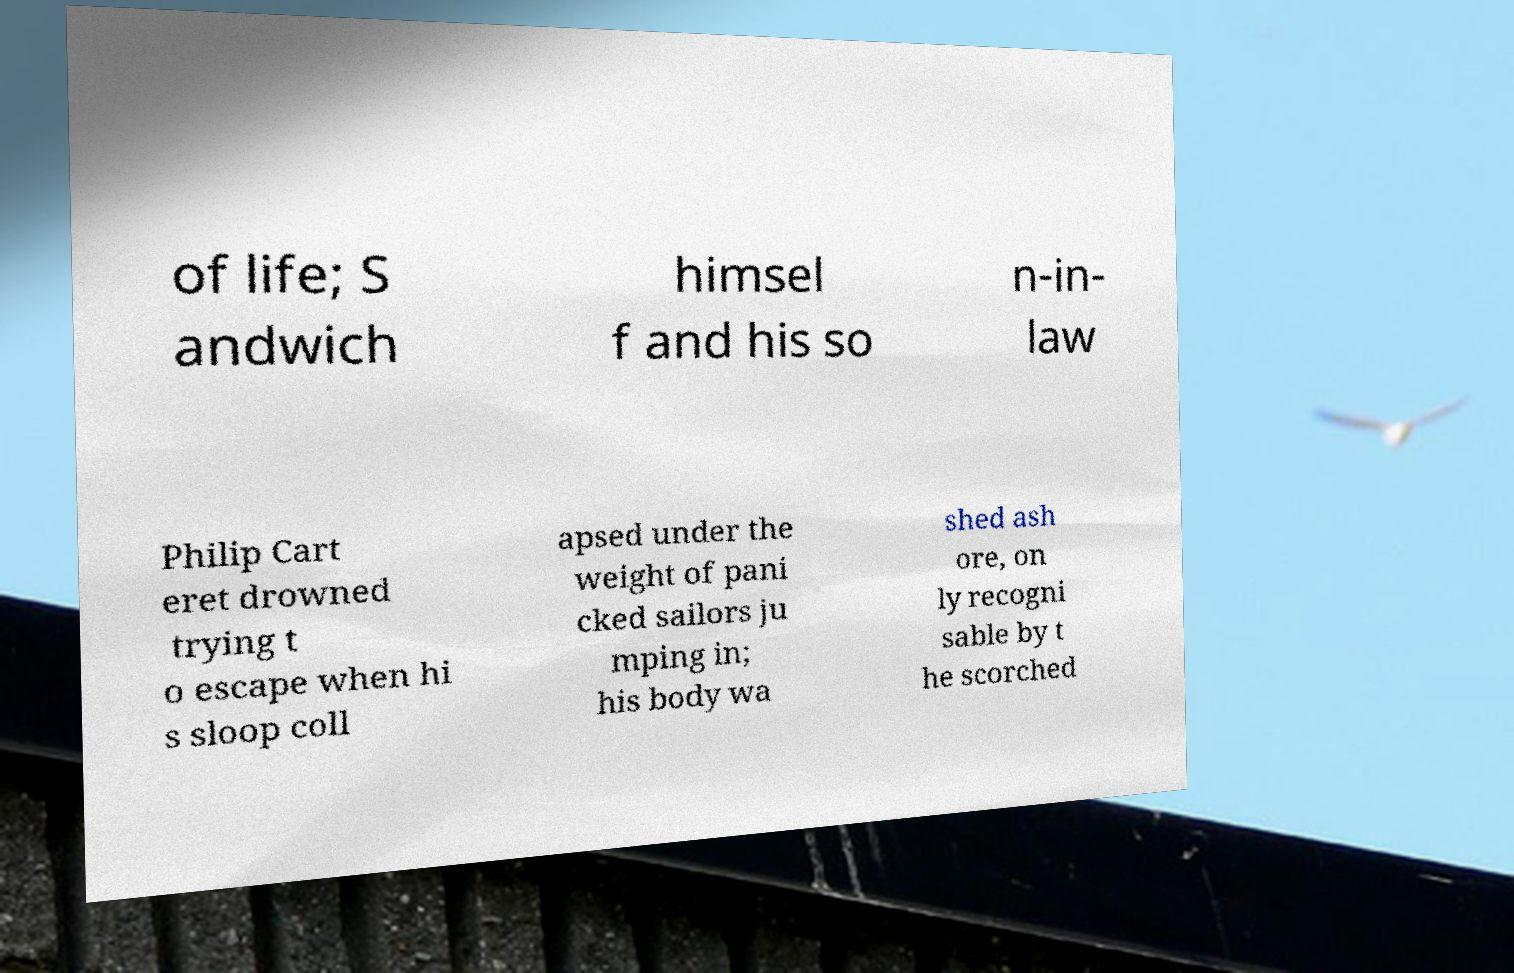Could you extract and type out the text from this image? of life; S andwich himsel f and his so n-in- law Philip Cart eret drowned trying t o escape when hi s sloop coll apsed under the weight of pani cked sailors ju mping in; his body wa shed ash ore, on ly recogni sable by t he scorched 